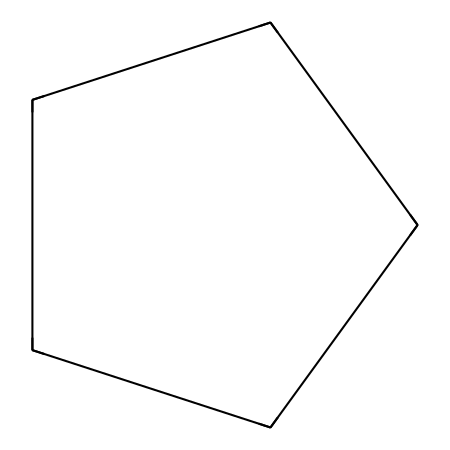What is the molecular formula of cyclopentane? Cyclopentane consists of 5 carbon atoms and 10 hydrogen atoms. Therefore, its molecular formula is C5H10.
Answer: C5H10 How many carbon atoms are in cyclopentane? The structure of cyclopentane is represented with five vertices, each indicating a carbon atom.
Answer: 5 What type of hydrocarbon is cyclopentane? Cyclopentane contains a closed ring of carbon atoms (with only single bonds), categorizing it as a cycloalkane.
Answer: cycloalkane What is the total number of hydrogen atoms in cyclopentane? In the cycloalkane structure, each carbon in cyclopentane is bonded to two hydrogen atoms (two hydrogens per carbon). With five carbon atoms, cyclopentane has a total of 10 hydrogen atoms.
Answer: 10 What type of bonding is present in cyclopentane? Cyclopentane's structure shows only single covalent bonds connecting the carbon atoms, indicating it involves sigma bonds.
Answer: single bonds What is the significance of cyclopentane in semiconductor manufacturing? Cyclopentane is used as a solvent in semiconductor processes due to its stability and ability to dissolve certain materials efficiently.
Answer: solvent How does cyclopentane's structure influence its boiling point compared to straight-chain alkanes? The cyclic arrangement leads to increased molecular interaction, resulting in a higher boiling point than straight-chain alkanes with similar carbon numbers.
Answer: higher boiling point 